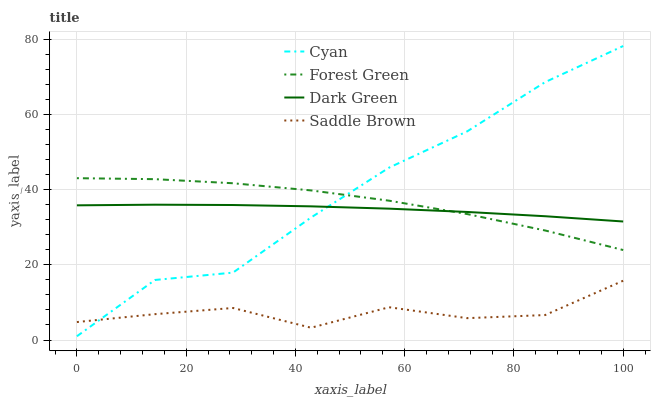Does Forest Green have the minimum area under the curve?
Answer yes or no. No. Does Forest Green have the maximum area under the curve?
Answer yes or no. No. Is Forest Green the smoothest?
Answer yes or no. No. Is Forest Green the roughest?
Answer yes or no. No. Does Forest Green have the lowest value?
Answer yes or no. No. Does Forest Green have the highest value?
Answer yes or no. No. Is Saddle Brown less than Dark Green?
Answer yes or no. Yes. Is Dark Green greater than Saddle Brown?
Answer yes or no. Yes. Does Saddle Brown intersect Dark Green?
Answer yes or no. No. 